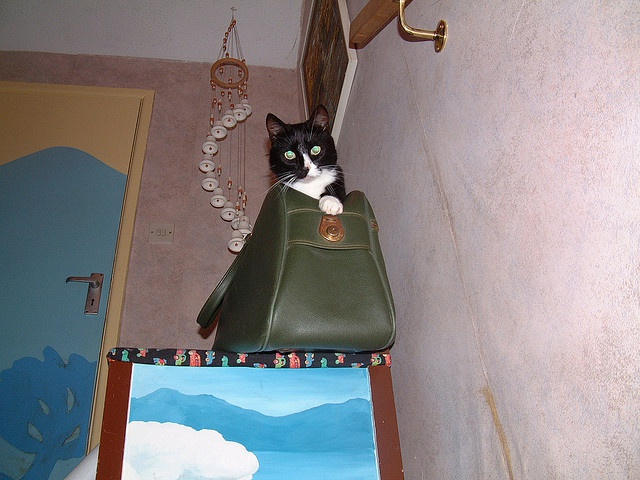Describe the objects in this image and their specific colors. I can see handbag in gray, black, and darkgreen tones and cat in gray, black, lightgray, and darkgray tones in this image. 